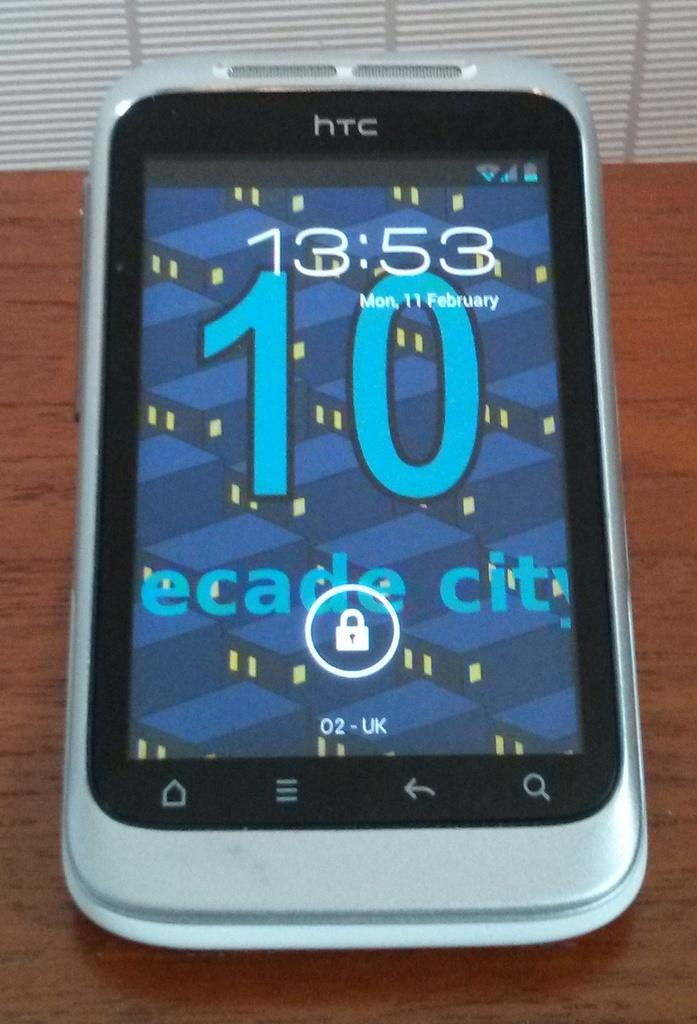Provide a one-sentence caption for the provided image. The phone on the table shows the date which is Monday, 11th February. 